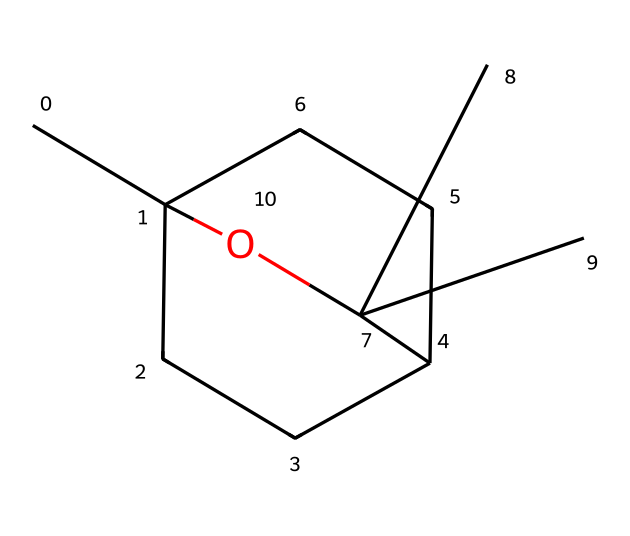What is the molecular formula of eucalyptol? To determine the molecular formula, count the number of carbon, hydrogen, and oxygen atoms in the given structure. There are 10 carbon atoms, 18 hydrogen atoms, and 1 oxygen atom, resulting in the molecular formula C10H18O.
Answer: C10H18O How many rings are present in the structure of eucalyptol? By inspecting the SMILES representation, we can observe two numbers indicating ring formations (1 and 2). This signifies that there are two ring structures present in the eucalyptol molecule.
Answer: 2 What is the type of functional group in eucalyptol? The presence of the hydroxyl group (-OH) in the structure indicates that eucalyptol contains an alcohol functional group. This is explicitly shown in the structural formula as a branching point off the carbon chain.
Answer: alcohol Which hydrocarbons category does eucalyptol belong to? Eucalyptol is classified under the terpenoid family, specifically being a monoterpene as it is derived from two isoprene units, which is often indicated in its structure containing multiple carbon rings.
Answer: terpenoid Does eucalyptol contain any double bonds? Analyzing the SMILES representation, all carbon atoms are connected by single bonds or saturated bonding, confirming that eucalyptol does not possess any double bonds in its structure.
Answer: no What is the total number of hydrogen atoms in eucalyptol? In the molecular formula C10H18O, the subscript indicates there are a total of 18 hydrogen atoms associated with the eucalyptol structure, derived from balancing the carbons and oxygen in the total as shown.
Answer: 18 